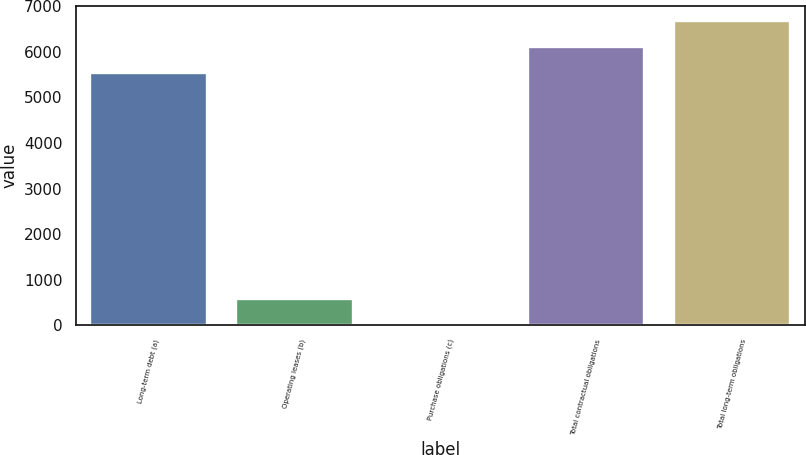Convert chart. <chart><loc_0><loc_0><loc_500><loc_500><bar_chart><fcel>Long-term debt (a)<fcel>Operating leases (b)<fcel>Purchase obligations (c)<fcel>Total contractual obligations<fcel>Total long-term obligations<nl><fcel>5548.1<fcel>568.31<fcel>7.2<fcel>6109.21<fcel>6670.32<nl></chart> 